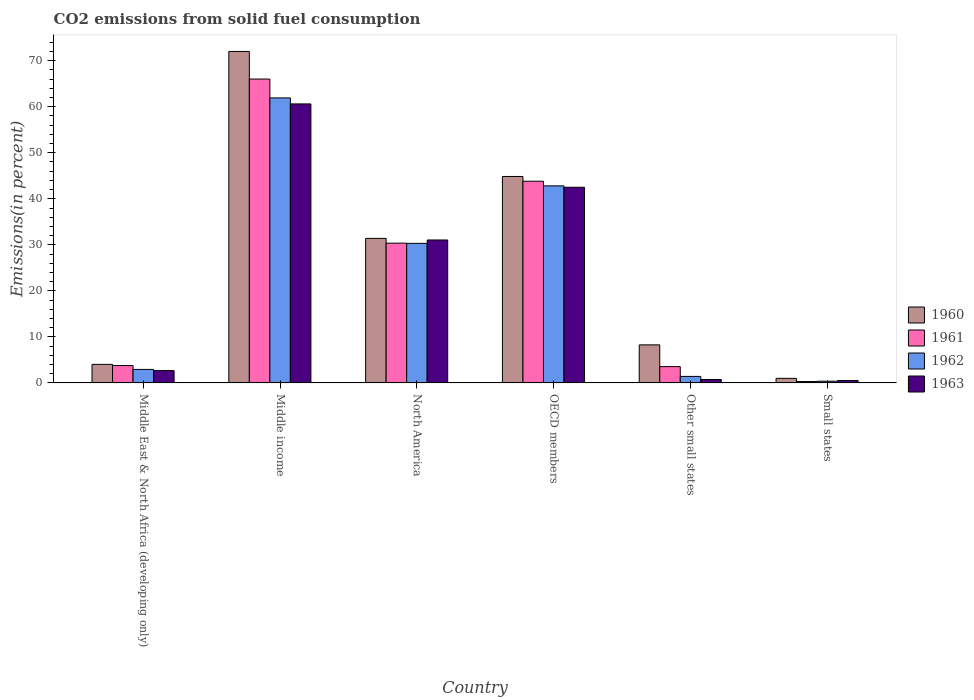How many different coloured bars are there?
Your answer should be very brief. 4. How many groups of bars are there?
Provide a short and direct response. 6. Are the number of bars per tick equal to the number of legend labels?
Give a very brief answer. Yes. What is the label of the 5th group of bars from the left?
Ensure brevity in your answer.  Other small states. What is the total CO2 emitted in 1963 in OECD members?
Keep it short and to the point. 42.51. Across all countries, what is the maximum total CO2 emitted in 1960?
Keep it short and to the point. 72.02. Across all countries, what is the minimum total CO2 emitted in 1961?
Provide a short and direct response. 0.31. In which country was the total CO2 emitted in 1963 minimum?
Your answer should be very brief. Small states. What is the total total CO2 emitted in 1962 in the graph?
Give a very brief answer. 139.8. What is the difference between the total CO2 emitted in 1961 in Middle income and that in Small states?
Your response must be concise. 65.71. What is the difference between the total CO2 emitted in 1962 in Middle income and the total CO2 emitted in 1960 in Other small states?
Keep it short and to the point. 53.65. What is the average total CO2 emitted in 1962 per country?
Keep it short and to the point. 23.3. What is the difference between the total CO2 emitted of/in 1961 and total CO2 emitted of/in 1962 in Middle East & North Africa (developing only)?
Ensure brevity in your answer.  0.84. What is the ratio of the total CO2 emitted in 1962 in Middle income to that in North America?
Offer a terse response. 2.04. Is the total CO2 emitted in 1961 in North America less than that in Small states?
Give a very brief answer. No. Is the difference between the total CO2 emitted in 1961 in Middle income and Other small states greater than the difference between the total CO2 emitted in 1962 in Middle income and Other small states?
Your answer should be very brief. Yes. What is the difference between the highest and the second highest total CO2 emitted in 1961?
Offer a very short reply. 22.2. What is the difference between the highest and the lowest total CO2 emitted in 1963?
Make the answer very short. 60.09. Is it the case that in every country, the sum of the total CO2 emitted in 1960 and total CO2 emitted in 1961 is greater than the total CO2 emitted in 1963?
Give a very brief answer. Yes. How many bars are there?
Make the answer very short. 24. How many countries are there in the graph?
Make the answer very short. 6. How are the legend labels stacked?
Give a very brief answer. Vertical. What is the title of the graph?
Your answer should be very brief. CO2 emissions from solid fuel consumption. What is the label or title of the Y-axis?
Offer a very short reply. Emissions(in percent). What is the Emissions(in percent) in 1960 in Middle East & North Africa (developing only)?
Your answer should be very brief. 4.03. What is the Emissions(in percent) of 1961 in Middle East & North Africa (developing only)?
Ensure brevity in your answer.  3.78. What is the Emissions(in percent) in 1962 in Middle East & North Africa (developing only)?
Your response must be concise. 2.94. What is the Emissions(in percent) of 1963 in Middle East & North Africa (developing only)?
Offer a very short reply. 2.68. What is the Emissions(in percent) of 1960 in Middle income?
Keep it short and to the point. 72.02. What is the Emissions(in percent) of 1961 in Middle income?
Your answer should be compact. 66.02. What is the Emissions(in percent) of 1962 in Middle income?
Your answer should be very brief. 61.92. What is the Emissions(in percent) in 1963 in Middle income?
Provide a succinct answer. 60.62. What is the Emissions(in percent) in 1960 in North America?
Your answer should be very brief. 31.4. What is the Emissions(in percent) in 1961 in North America?
Keep it short and to the point. 30.37. What is the Emissions(in percent) in 1962 in North America?
Offer a terse response. 30.32. What is the Emissions(in percent) in 1963 in North America?
Offer a very short reply. 31.06. What is the Emissions(in percent) of 1960 in OECD members?
Your answer should be very brief. 44.86. What is the Emissions(in percent) in 1961 in OECD members?
Provide a short and direct response. 43.82. What is the Emissions(in percent) in 1962 in OECD members?
Your answer should be very brief. 42.82. What is the Emissions(in percent) in 1963 in OECD members?
Your response must be concise. 42.51. What is the Emissions(in percent) of 1960 in Other small states?
Give a very brief answer. 8.27. What is the Emissions(in percent) in 1961 in Other small states?
Your response must be concise. 3.55. What is the Emissions(in percent) of 1962 in Other small states?
Ensure brevity in your answer.  1.42. What is the Emissions(in percent) in 1963 in Other small states?
Your answer should be very brief. 0.75. What is the Emissions(in percent) of 1960 in Small states?
Your response must be concise. 1. What is the Emissions(in percent) of 1961 in Small states?
Make the answer very short. 0.31. What is the Emissions(in percent) of 1962 in Small states?
Give a very brief answer. 0.38. What is the Emissions(in percent) of 1963 in Small states?
Your response must be concise. 0.53. Across all countries, what is the maximum Emissions(in percent) in 1960?
Give a very brief answer. 72.02. Across all countries, what is the maximum Emissions(in percent) in 1961?
Offer a very short reply. 66.02. Across all countries, what is the maximum Emissions(in percent) of 1962?
Offer a terse response. 61.92. Across all countries, what is the maximum Emissions(in percent) of 1963?
Make the answer very short. 60.62. Across all countries, what is the minimum Emissions(in percent) in 1960?
Offer a very short reply. 1. Across all countries, what is the minimum Emissions(in percent) of 1961?
Offer a terse response. 0.31. Across all countries, what is the minimum Emissions(in percent) of 1962?
Give a very brief answer. 0.38. Across all countries, what is the minimum Emissions(in percent) in 1963?
Your answer should be very brief. 0.53. What is the total Emissions(in percent) of 1960 in the graph?
Offer a very short reply. 161.58. What is the total Emissions(in percent) of 1961 in the graph?
Give a very brief answer. 147.84. What is the total Emissions(in percent) of 1962 in the graph?
Your response must be concise. 139.8. What is the total Emissions(in percent) in 1963 in the graph?
Offer a terse response. 138.15. What is the difference between the Emissions(in percent) in 1960 in Middle East & North Africa (developing only) and that in Middle income?
Give a very brief answer. -67.99. What is the difference between the Emissions(in percent) of 1961 in Middle East & North Africa (developing only) and that in Middle income?
Offer a terse response. -62.24. What is the difference between the Emissions(in percent) of 1962 in Middle East & North Africa (developing only) and that in Middle income?
Keep it short and to the point. -58.99. What is the difference between the Emissions(in percent) in 1963 in Middle East & North Africa (developing only) and that in Middle income?
Offer a terse response. -57.94. What is the difference between the Emissions(in percent) in 1960 in Middle East & North Africa (developing only) and that in North America?
Offer a very short reply. -27.37. What is the difference between the Emissions(in percent) in 1961 in Middle East & North Africa (developing only) and that in North America?
Provide a succinct answer. -26.59. What is the difference between the Emissions(in percent) in 1962 in Middle East & North Africa (developing only) and that in North America?
Keep it short and to the point. -27.38. What is the difference between the Emissions(in percent) in 1963 in Middle East & North Africa (developing only) and that in North America?
Ensure brevity in your answer.  -28.38. What is the difference between the Emissions(in percent) of 1960 in Middle East & North Africa (developing only) and that in OECD members?
Provide a succinct answer. -40.82. What is the difference between the Emissions(in percent) of 1961 in Middle East & North Africa (developing only) and that in OECD members?
Offer a terse response. -40.05. What is the difference between the Emissions(in percent) in 1962 in Middle East & North Africa (developing only) and that in OECD members?
Offer a very short reply. -39.88. What is the difference between the Emissions(in percent) in 1963 in Middle East & North Africa (developing only) and that in OECD members?
Your response must be concise. -39.83. What is the difference between the Emissions(in percent) in 1960 in Middle East & North Africa (developing only) and that in Other small states?
Offer a terse response. -4.24. What is the difference between the Emissions(in percent) in 1961 in Middle East & North Africa (developing only) and that in Other small states?
Keep it short and to the point. 0.23. What is the difference between the Emissions(in percent) in 1962 in Middle East & North Africa (developing only) and that in Other small states?
Give a very brief answer. 1.52. What is the difference between the Emissions(in percent) of 1963 in Middle East & North Africa (developing only) and that in Other small states?
Offer a terse response. 1.93. What is the difference between the Emissions(in percent) of 1960 in Middle East & North Africa (developing only) and that in Small states?
Provide a succinct answer. 3.03. What is the difference between the Emissions(in percent) of 1961 in Middle East & North Africa (developing only) and that in Small states?
Offer a terse response. 3.47. What is the difference between the Emissions(in percent) of 1962 in Middle East & North Africa (developing only) and that in Small states?
Ensure brevity in your answer.  2.56. What is the difference between the Emissions(in percent) of 1963 in Middle East & North Africa (developing only) and that in Small states?
Offer a very short reply. 2.15. What is the difference between the Emissions(in percent) of 1960 in Middle income and that in North America?
Offer a terse response. 40.61. What is the difference between the Emissions(in percent) in 1961 in Middle income and that in North America?
Provide a short and direct response. 35.65. What is the difference between the Emissions(in percent) of 1962 in Middle income and that in North America?
Give a very brief answer. 31.6. What is the difference between the Emissions(in percent) in 1963 in Middle income and that in North America?
Offer a very short reply. 29.56. What is the difference between the Emissions(in percent) of 1960 in Middle income and that in OECD members?
Offer a terse response. 27.16. What is the difference between the Emissions(in percent) of 1961 in Middle income and that in OECD members?
Your response must be concise. 22.2. What is the difference between the Emissions(in percent) of 1962 in Middle income and that in OECD members?
Provide a succinct answer. 19.11. What is the difference between the Emissions(in percent) of 1963 in Middle income and that in OECD members?
Offer a terse response. 18.11. What is the difference between the Emissions(in percent) of 1960 in Middle income and that in Other small states?
Provide a short and direct response. 63.75. What is the difference between the Emissions(in percent) in 1961 in Middle income and that in Other small states?
Offer a terse response. 62.47. What is the difference between the Emissions(in percent) of 1962 in Middle income and that in Other small states?
Make the answer very short. 60.51. What is the difference between the Emissions(in percent) in 1963 in Middle income and that in Other small states?
Offer a very short reply. 59.87. What is the difference between the Emissions(in percent) in 1960 in Middle income and that in Small states?
Offer a terse response. 71.02. What is the difference between the Emissions(in percent) of 1961 in Middle income and that in Small states?
Provide a short and direct response. 65.71. What is the difference between the Emissions(in percent) in 1962 in Middle income and that in Small states?
Provide a short and direct response. 61.55. What is the difference between the Emissions(in percent) in 1963 in Middle income and that in Small states?
Provide a succinct answer. 60.09. What is the difference between the Emissions(in percent) of 1960 in North America and that in OECD members?
Give a very brief answer. -13.45. What is the difference between the Emissions(in percent) in 1961 in North America and that in OECD members?
Ensure brevity in your answer.  -13.45. What is the difference between the Emissions(in percent) of 1962 in North America and that in OECD members?
Give a very brief answer. -12.49. What is the difference between the Emissions(in percent) of 1963 in North America and that in OECD members?
Your answer should be compact. -11.45. What is the difference between the Emissions(in percent) of 1960 in North America and that in Other small states?
Offer a terse response. 23.13. What is the difference between the Emissions(in percent) of 1961 in North America and that in Other small states?
Provide a succinct answer. 26.82. What is the difference between the Emissions(in percent) of 1962 in North America and that in Other small states?
Keep it short and to the point. 28.9. What is the difference between the Emissions(in percent) in 1963 in North America and that in Other small states?
Keep it short and to the point. 30.31. What is the difference between the Emissions(in percent) of 1960 in North America and that in Small states?
Your answer should be very brief. 30.4. What is the difference between the Emissions(in percent) of 1961 in North America and that in Small states?
Your answer should be compact. 30.06. What is the difference between the Emissions(in percent) in 1962 in North America and that in Small states?
Make the answer very short. 29.95. What is the difference between the Emissions(in percent) of 1963 in North America and that in Small states?
Your answer should be very brief. 30.53. What is the difference between the Emissions(in percent) in 1960 in OECD members and that in Other small states?
Offer a terse response. 36.58. What is the difference between the Emissions(in percent) of 1961 in OECD members and that in Other small states?
Offer a very short reply. 40.28. What is the difference between the Emissions(in percent) of 1962 in OECD members and that in Other small states?
Provide a succinct answer. 41.4. What is the difference between the Emissions(in percent) in 1963 in OECD members and that in Other small states?
Your answer should be compact. 41.77. What is the difference between the Emissions(in percent) of 1960 in OECD members and that in Small states?
Keep it short and to the point. 43.86. What is the difference between the Emissions(in percent) in 1961 in OECD members and that in Small states?
Your response must be concise. 43.52. What is the difference between the Emissions(in percent) of 1962 in OECD members and that in Small states?
Provide a short and direct response. 42.44. What is the difference between the Emissions(in percent) in 1963 in OECD members and that in Small states?
Offer a very short reply. 41.98. What is the difference between the Emissions(in percent) in 1960 in Other small states and that in Small states?
Your response must be concise. 7.27. What is the difference between the Emissions(in percent) of 1961 in Other small states and that in Small states?
Offer a terse response. 3.24. What is the difference between the Emissions(in percent) in 1962 in Other small states and that in Small states?
Make the answer very short. 1.04. What is the difference between the Emissions(in percent) of 1963 in Other small states and that in Small states?
Provide a succinct answer. 0.21. What is the difference between the Emissions(in percent) in 1960 in Middle East & North Africa (developing only) and the Emissions(in percent) in 1961 in Middle income?
Offer a terse response. -61.99. What is the difference between the Emissions(in percent) in 1960 in Middle East & North Africa (developing only) and the Emissions(in percent) in 1962 in Middle income?
Provide a succinct answer. -57.89. What is the difference between the Emissions(in percent) in 1960 in Middle East & North Africa (developing only) and the Emissions(in percent) in 1963 in Middle income?
Your answer should be very brief. -56.59. What is the difference between the Emissions(in percent) of 1961 in Middle East & North Africa (developing only) and the Emissions(in percent) of 1962 in Middle income?
Your answer should be compact. -58.15. What is the difference between the Emissions(in percent) in 1961 in Middle East & North Africa (developing only) and the Emissions(in percent) in 1963 in Middle income?
Offer a terse response. -56.84. What is the difference between the Emissions(in percent) in 1962 in Middle East & North Africa (developing only) and the Emissions(in percent) in 1963 in Middle income?
Give a very brief answer. -57.68. What is the difference between the Emissions(in percent) in 1960 in Middle East & North Africa (developing only) and the Emissions(in percent) in 1961 in North America?
Provide a short and direct response. -26.34. What is the difference between the Emissions(in percent) of 1960 in Middle East & North Africa (developing only) and the Emissions(in percent) of 1962 in North America?
Keep it short and to the point. -26.29. What is the difference between the Emissions(in percent) in 1960 in Middle East & North Africa (developing only) and the Emissions(in percent) in 1963 in North America?
Give a very brief answer. -27.03. What is the difference between the Emissions(in percent) in 1961 in Middle East & North Africa (developing only) and the Emissions(in percent) in 1962 in North America?
Provide a succinct answer. -26.55. What is the difference between the Emissions(in percent) in 1961 in Middle East & North Africa (developing only) and the Emissions(in percent) in 1963 in North America?
Make the answer very short. -27.28. What is the difference between the Emissions(in percent) of 1962 in Middle East & North Africa (developing only) and the Emissions(in percent) of 1963 in North America?
Provide a succinct answer. -28.12. What is the difference between the Emissions(in percent) in 1960 in Middle East & North Africa (developing only) and the Emissions(in percent) in 1961 in OECD members?
Ensure brevity in your answer.  -39.79. What is the difference between the Emissions(in percent) of 1960 in Middle East & North Africa (developing only) and the Emissions(in percent) of 1962 in OECD members?
Your answer should be compact. -38.79. What is the difference between the Emissions(in percent) in 1960 in Middle East & North Africa (developing only) and the Emissions(in percent) in 1963 in OECD members?
Offer a terse response. -38.48. What is the difference between the Emissions(in percent) of 1961 in Middle East & North Africa (developing only) and the Emissions(in percent) of 1962 in OECD members?
Your answer should be very brief. -39.04. What is the difference between the Emissions(in percent) of 1961 in Middle East & North Africa (developing only) and the Emissions(in percent) of 1963 in OECD members?
Keep it short and to the point. -38.74. What is the difference between the Emissions(in percent) in 1962 in Middle East & North Africa (developing only) and the Emissions(in percent) in 1963 in OECD members?
Provide a succinct answer. -39.57. What is the difference between the Emissions(in percent) of 1960 in Middle East & North Africa (developing only) and the Emissions(in percent) of 1961 in Other small states?
Keep it short and to the point. 0.48. What is the difference between the Emissions(in percent) of 1960 in Middle East & North Africa (developing only) and the Emissions(in percent) of 1962 in Other small states?
Give a very brief answer. 2.61. What is the difference between the Emissions(in percent) of 1960 in Middle East & North Africa (developing only) and the Emissions(in percent) of 1963 in Other small states?
Make the answer very short. 3.28. What is the difference between the Emissions(in percent) of 1961 in Middle East & North Africa (developing only) and the Emissions(in percent) of 1962 in Other small states?
Keep it short and to the point. 2.36. What is the difference between the Emissions(in percent) in 1961 in Middle East & North Africa (developing only) and the Emissions(in percent) in 1963 in Other small states?
Make the answer very short. 3.03. What is the difference between the Emissions(in percent) of 1962 in Middle East & North Africa (developing only) and the Emissions(in percent) of 1963 in Other small states?
Your answer should be compact. 2.19. What is the difference between the Emissions(in percent) of 1960 in Middle East & North Africa (developing only) and the Emissions(in percent) of 1961 in Small states?
Give a very brief answer. 3.72. What is the difference between the Emissions(in percent) of 1960 in Middle East & North Africa (developing only) and the Emissions(in percent) of 1962 in Small states?
Offer a very short reply. 3.65. What is the difference between the Emissions(in percent) of 1960 in Middle East & North Africa (developing only) and the Emissions(in percent) of 1963 in Small states?
Offer a very short reply. 3.5. What is the difference between the Emissions(in percent) in 1961 in Middle East & North Africa (developing only) and the Emissions(in percent) in 1962 in Small states?
Your answer should be very brief. 3.4. What is the difference between the Emissions(in percent) in 1961 in Middle East & North Africa (developing only) and the Emissions(in percent) in 1963 in Small states?
Your response must be concise. 3.24. What is the difference between the Emissions(in percent) of 1962 in Middle East & North Africa (developing only) and the Emissions(in percent) of 1963 in Small states?
Provide a succinct answer. 2.4. What is the difference between the Emissions(in percent) in 1960 in Middle income and the Emissions(in percent) in 1961 in North America?
Offer a terse response. 41.65. What is the difference between the Emissions(in percent) of 1960 in Middle income and the Emissions(in percent) of 1962 in North America?
Keep it short and to the point. 41.7. What is the difference between the Emissions(in percent) in 1960 in Middle income and the Emissions(in percent) in 1963 in North America?
Offer a terse response. 40.96. What is the difference between the Emissions(in percent) of 1961 in Middle income and the Emissions(in percent) of 1962 in North America?
Your answer should be compact. 35.7. What is the difference between the Emissions(in percent) in 1961 in Middle income and the Emissions(in percent) in 1963 in North America?
Your answer should be very brief. 34.96. What is the difference between the Emissions(in percent) in 1962 in Middle income and the Emissions(in percent) in 1963 in North America?
Your response must be concise. 30.86. What is the difference between the Emissions(in percent) of 1960 in Middle income and the Emissions(in percent) of 1961 in OECD members?
Offer a terse response. 28.2. What is the difference between the Emissions(in percent) in 1960 in Middle income and the Emissions(in percent) in 1962 in OECD members?
Offer a very short reply. 29.2. What is the difference between the Emissions(in percent) in 1960 in Middle income and the Emissions(in percent) in 1963 in OECD members?
Offer a very short reply. 29.51. What is the difference between the Emissions(in percent) in 1961 in Middle income and the Emissions(in percent) in 1962 in OECD members?
Ensure brevity in your answer.  23.2. What is the difference between the Emissions(in percent) in 1961 in Middle income and the Emissions(in percent) in 1963 in OECD members?
Offer a very short reply. 23.51. What is the difference between the Emissions(in percent) in 1962 in Middle income and the Emissions(in percent) in 1963 in OECD members?
Provide a succinct answer. 19.41. What is the difference between the Emissions(in percent) in 1960 in Middle income and the Emissions(in percent) in 1961 in Other small states?
Your answer should be very brief. 68.47. What is the difference between the Emissions(in percent) in 1960 in Middle income and the Emissions(in percent) in 1962 in Other small states?
Your answer should be compact. 70.6. What is the difference between the Emissions(in percent) of 1960 in Middle income and the Emissions(in percent) of 1963 in Other small states?
Ensure brevity in your answer.  71.27. What is the difference between the Emissions(in percent) in 1961 in Middle income and the Emissions(in percent) in 1962 in Other small states?
Your answer should be very brief. 64.6. What is the difference between the Emissions(in percent) of 1961 in Middle income and the Emissions(in percent) of 1963 in Other small states?
Your answer should be very brief. 65.27. What is the difference between the Emissions(in percent) in 1962 in Middle income and the Emissions(in percent) in 1963 in Other small states?
Your answer should be compact. 61.18. What is the difference between the Emissions(in percent) of 1960 in Middle income and the Emissions(in percent) of 1961 in Small states?
Provide a short and direct response. 71.71. What is the difference between the Emissions(in percent) in 1960 in Middle income and the Emissions(in percent) in 1962 in Small states?
Keep it short and to the point. 71.64. What is the difference between the Emissions(in percent) of 1960 in Middle income and the Emissions(in percent) of 1963 in Small states?
Provide a short and direct response. 71.48. What is the difference between the Emissions(in percent) in 1961 in Middle income and the Emissions(in percent) in 1962 in Small states?
Give a very brief answer. 65.64. What is the difference between the Emissions(in percent) in 1961 in Middle income and the Emissions(in percent) in 1963 in Small states?
Provide a short and direct response. 65.48. What is the difference between the Emissions(in percent) in 1962 in Middle income and the Emissions(in percent) in 1963 in Small states?
Offer a very short reply. 61.39. What is the difference between the Emissions(in percent) of 1960 in North America and the Emissions(in percent) of 1961 in OECD members?
Keep it short and to the point. -12.42. What is the difference between the Emissions(in percent) of 1960 in North America and the Emissions(in percent) of 1962 in OECD members?
Ensure brevity in your answer.  -11.41. What is the difference between the Emissions(in percent) of 1960 in North America and the Emissions(in percent) of 1963 in OECD members?
Provide a succinct answer. -11.11. What is the difference between the Emissions(in percent) of 1961 in North America and the Emissions(in percent) of 1962 in OECD members?
Make the answer very short. -12.45. What is the difference between the Emissions(in percent) of 1961 in North America and the Emissions(in percent) of 1963 in OECD members?
Keep it short and to the point. -12.14. What is the difference between the Emissions(in percent) in 1962 in North America and the Emissions(in percent) in 1963 in OECD members?
Your answer should be very brief. -12.19. What is the difference between the Emissions(in percent) in 1960 in North America and the Emissions(in percent) in 1961 in Other small states?
Provide a short and direct response. 27.86. What is the difference between the Emissions(in percent) in 1960 in North America and the Emissions(in percent) in 1962 in Other small states?
Offer a very short reply. 29.98. What is the difference between the Emissions(in percent) in 1960 in North America and the Emissions(in percent) in 1963 in Other small states?
Provide a short and direct response. 30.66. What is the difference between the Emissions(in percent) in 1961 in North America and the Emissions(in percent) in 1962 in Other small states?
Your answer should be very brief. 28.95. What is the difference between the Emissions(in percent) of 1961 in North America and the Emissions(in percent) of 1963 in Other small states?
Provide a short and direct response. 29.62. What is the difference between the Emissions(in percent) of 1962 in North America and the Emissions(in percent) of 1963 in Other small states?
Make the answer very short. 29.58. What is the difference between the Emissions(in percent) of 1960 in North America and the Emissions(in percent) of 1961 in Small states?
Your answer should be compact. 31.1. What is the difference between the Emissions(in percent) of 1960 in North America and the Emissions(in percent) of 1962 in Small states?
Provide a short and direct response. 31.03. What is the difference between the Emissions(in percent) in 1960 in North America and the Emissions(in percent) in 1963 in Small states?
Give a very brief answer. 30.87. What is the difference between the Emissions(in percent) of 1961 in North America and the Emissions(in percent) of 1962 in Small states?
Offer a very short reply. 29.99. What is the difference between the Emissions(in percent) in 1961 in North America and the Emissions(in percent) in 1963 in Small states?
Make the answer very short. 29.84. What is the difference between the Emissions(in percent) in 1962 in North America and the Emissions(in percent) in 1963 in Small states?
Make the answer very short. 29.79. What is the difference between the Emissions(in percent) of 1960 in OECD members and the Emissions(in percent) of 1961 in Other small states?
Provide a succinct answer. 41.31. What is the difference between the Emissions(in percent) in 1960 in OECD members and the Emissions(in percent) in 1962 in Other small states?
Offer a very short reply. 43.44. What is the difference between the Emissions(in percent) in 1960 in OECD members and the Emissions(in percent) in 1963 in Other small states?
Offer a very short reply. 44.11. What is the difference between the Emissions(in percent) of 1961 in OECD members and the Emissions(in percent) of 1962 in Other small states?
Offer a terse response. 42.4. What is the difference between the Emissions(in percent) in 1961 in OECD members and the Emissions(in percent) in 1963 in Other small states?
Make the answer very short. 43.08. What is the difference between the Emissions(in percent) in 1962 in OECD members and the Emissions(in percent) in 1963 in Other small states?
Give a very brief answer. 42.07. What is the difference between the Emissions(in percent) of 1960 in OECD members and the Emissions(in percent) of 1961 in Small states?
Offer a terse response. 44.55. What is the difference between the Emissions(in percent) of 1960 in OECD members and the Emissions(in percent) of 1962 in Small states?
Your response must be concise. 44.48. What is the difference between the Emissions(in percent) of 1960 in OECD members and the Emissions(in percent) of 1963 in Small states?
Your answer should be very brief. 44.32. What is the difference between the Emissions(in percent) in 1961 in OECD members and the Emissions(in percent) in 1962 in Small states?
Keep it short and to the point. 43.45. What is the difference between the Emissions(in percent) of 1961 in OECD members and the Emissions(in percent) of 1963 in Small states?
Make the answer very short. 43.29. What is the difference between the Emissions(in percent) of 1962 in OECD members and the Emissions(in percent) of 1963 in Small states?
Make the answer very short. 42.28. What is the difference between the Emissions(in percent) in 1960 in Other small states and the Emissions(in percent) in 1961 in Small states?
Offer a terse response. 7.96. What is the difference between the Emissions(in percent) of 1960 in Other small states and the Emissions(in percent) of 1962 in Small states?
Provide a short and direct response. 7.89. What is the difference between the Emissions(in percent) in 1960 in Other small states and the Emissions(in percent) in 1963 in Small states?
Your answer should be compact. 7.74. What is the difference between the Emissions(in percent) in 1961 in Other small states and the Emissions(in percent) in 1962 in Small states?
Provide a short and direct response. 3.17. What is the difference between the Emissions(in percent) of 1961 in Other small states and the Emissions(in percent) of 1963 in Small states?
Provide a succinct answer. 3.01. What is the difference between the Emissions(in percent) in 1962 in Other small states and the Emissions(in percent) in 1963 in Small states?
Offer a very short reply. 0.88. What is the average Emissions(in percent) of 1960 per country?
Your answer should be compact. 26.93. What is the average Emissions(in percent) in 1961 per country?
Your answer should be very brief. 24.64. What is the average Emissions(in percent) of 1962 per country?
Give a very brief answer. 23.3. What is the average Emissions(in percent) of 1963 per country?
Keep it short and to the point. 23.03. What is the difference between the Emissions(in percent) in 1960 and Emissions(in percent) in 1961 in Middle East & North Africa (developing only)?
Keep it short and to the point. 0.25. What is the difference between the Emissions(in percent) in 1960 and Emissions(in percent) in 1962 in Middle East & North Africa (developing only)?
Your response must be concise. 1.09. What is the difference between the Emissions(in percent) of 1960 and Emissions(in percent) of 1963 in Middle East & North Africa (developing only)?
Ensure brevity in your answer.  1.35. What is the difference between the Emissions(in percent) in 1961 and Emissions(in percent) in 1962 in Middle East & North Africa (developing only)?
Offer a very short reply. 0.84. What is the difference between the Emissions(in percent) of 1961 and Emissions(in percent) of 1963 in Middle East & North Africa (developing only)?
Your answer should be compact. 1.1. What is the difference between the Emissions(in percent) of 1962 and Emissions(in percent) of 1963 in Middle East & North Africa (developing only)?
Give a very brief answer. 0.26. What is the difference between the Emissions(in percent) in 1960 and Emissions(in percent) in 1961 in Middle income?
Offer a very short reply. 6. What is the difference between the Emissions(in percent) of 1960 and Emissions(in percent) of 1962 in Middle income?
Give a very brief answer. 10.09. What is the difference between the Emissions(in percent) of 1960 and Emissions(in percent) of 1963 in Middle income?
Offer a terse response. 11.4. What is the difference between the Emissions(in percent) of 1961 and Emissions(in percent) of 1962 in Middle income?
Give a very brief answer. 4.09. What is the difference between the Emissions(in percent) in 1961 and Emissions(in percent) in 1963 in Middle income?
Your answer should be very brief. 5.4. What is the difference between the Emissions(in percent) in 1962 and Emissions(in percent) in 1963 in Middle income?
Your response must be concise. 1.31. What is the difference between the Emissions(in percent) in 1960 and Emissions(in percent) in 1961 in North America?
Provide a succinct answer. 1.03. What is the difference between the Emissions(in percent) in 1960 and Emissions(in percent) in 1962 in North America?
Your answer should be compact. 1.08. What is the difference between the Emissions(in percent) in 1960 and Emissions(in percent) in 1963 in North America?
Give a very brief answer. 0.34. What is the difference between the Emissions(in percent) of 1961 and Emissions(in percent) of 1962 in North America?
Provide a succinct answer. 0.05. What is the difference between the Emissions(in percent) in 1961 and Emissions(in percent) in 1963 in North America?
Make the answer very short. -0.69. What is the difference between the Emissions(in percent) of 1962 and Emissions(in percent) of 1963 in North America?
Your answer should be very brief. -0.74. What is the difference between the Emissions(in percent) of 1960 and Emissions(in percent) of 1961 in OECD members?
Keep it short and to the point. 1.03. What is the difference between the Emissions(in percent) in 1960 and Emissions(in percent) in 1962 in OECD members?
Give a very brief answer. 2.04. What is the difference between the Emissions(in percent) in 1960 and Emissions(in percent) in 1963 in OECD members?
Offer a terse response. 2.34. What is the difference between the Emissions(in percent) in 1961 and Emissions(in percent) in 1963 in OECD members?
Your response must be concise. 1.31. What is the difference between the Emissions(in percent) of 1962 and Emissions(in percent) of 1963 in OECD members?
Offer a very short reply. 0.3. What is the difference between the Emissions(in percent) in 1960 and Emissions(in percent) in 1961 in Other small states?
Ensure brevity in your answer.  4.72. What is the difference between the Emissions(in percent) of 1960 and Emissions(in percent) of 1962 in Other small states?
Offer a very short reply. 6.85. What is the difference between the Emissions(in percent) in 1960 and Emissions(in percent) in 1963 in Other small states?
Your answer should be very brief. 7.52. What is the difference between the Emissions(in percent) in 1961 and Emissions(in percent) in 1962 in Other small states?
Your answer should be very brief. 2.13. What is the difference between the Emissions(in percent) in 1961 and Emissions(in percent) in 1963 in Other small states?
Offer a very short reply. 2.8. What is the difference between the Emissions(in percent) of 1962 and Emissions(in percent) of 1963 in Other small states?
Your answer should be very brief. 0.67. What is the difference between the Emissions(in percent) in 1960 and Emissions(in percent) in 1961 in Small states?
Give a very brief answer. 0.69. What is the difference between the Emissions(in percent) of 1960 and Emissions(in percent) of 1962 in Small states?
Provide a short and direct response. 0.62. What is the difference between the Emissions(in percent) in 1960 and Emissions(in percent) in 1963 in Small states?
Your response must be concise. 0.46. What is the difference between the Emissions(in percent) in 1961 and Emissions(in percent) in 1962 in Small states?
Keep it short and to the point. -0.07. What is the difference between the Emissions(in percent) of 1961 and Emissions(in percent) of 1963 in Small states?
Your response must be concise. -0.23. What is the difference between the Emissions(in percent) of 1962 and Emissions(in percent) of 1963 in Small states?
Your answer should be very brief. -0.16. What is the ratio of the Emissions(in percent) of 1960 in Middle East & North Africa (developing only) to that in Middle income?
Offer a very short reply. 0.06. What is the ratio of the Emissions(in percent) in 1961 in Middle East & North Africa (developing only) to that in Middle income?
Provide a succinct answer. 0.06. What is the ratio of the Emissions(in percent) of 1962 in Middle East & North Africa (developing only) to that in Middle income?
Provide a short and direct response. 0.05. What is the ratio of the Emissions(in percent) in 1963 in Middle East & North Africa (developing only) to that in Middle income?
Offer a very short reply. 0.04. What is the ratio of the Emissions(in percent) in 1960 in Middle East & North Africa (developing only) to that in North America?
Ensure brevity in your answer.  0.13. What is the ratio of the Emissions(in percent) of 1961 in Middle East & North Africa (developing only) to that in North America?
Your answer should be compact. 0.12. What is the ratio of the Emissions(in percent) of 1962 in Middle East & North Africa (developing only) to that in North America?
Make the answer very short. 0.1. What is the ratio of the Emissions(in percent) of 1963 in Middle East & North Africa (developing only) to that in North America?
Ensure brevity in your answer.  0.09. What is the ratio of the Emissions(in percent) in 1960 in Middle East & North Africa (developing only) to that in OECD members?
Keep it short and to the point. 0.09. What is the ratio of the Emissions(in percent) of 1961 in Middle East & North Africa (developing only) to that in OECD members?
Ensure brevity in your answer.  0.09. What is the ratio of the Emissions(in percent) of 1962 in Middle East & North Africa (developing only) to that in OECD members?
Keep it short and to the point. 0.07. What is the ratio of the Emissions(in percent) in 1963 in Middle East & North Africa (developing only) to that in OECD members?
Make the answer very short. 0.06. What is the ratio of the Emissions(in percent) of 1960 in Middle East & North Africa (developing only) to that in Other small states?
Provide a succinct answer. 0.49. What is the ratio of the Emissions(in percent) in 1961 in Middle East & North Africa (developing only) to that in Other small states?
Provide a short and direct response. 1.06. What is the ratio of the Emissions(in percent) of 1962 in Middle East & North Africa (developing only) to that in Other small states?
Provide a succinct answer. 2.07. What is the ratio of the Emissions(in percent) of 1963 in Middle East & North Africa (developing only) to that in Other small states?
Offer a terse response. 3.59. What is the ratio of the Emissions(in percent) in 1960 in Middle East & North Africa (developing only) to that in Small states?
Your response must be concise. 4.04. What is the ratio of the Emissions(in percent) of 1961 in Middle East & North Africa (developing only) to that in Small states?
Your response must be concise. 12.35. What is the ratio of the Emissions(in percent) of 1962 in Middle East & North Africa (developing only) to that in Small states?
Make the answer very short. 7.81. What is the ratio of the Emissions(in percent) of 1963 in Middle East & North Africa (developing only) to that in Small states?
Ensure brevity in your answer.  5.02. What is the ratio of the Emissions(in percent) of 1960 in Middle income to that in North America?
Offer a terse response. 2.29. What is the ratio of the Emissions(in percent) in 1961 in Middle income to that in North America?
Keep it short and to the point. 2.17. What is the ratio of the Emissions(in percent) of 1962 in Middle income to that in North America?
Your answer should be compact. 2.04. What is the ratio of the Emissions(in percent) of 1963 in Middle income to that in North America?
Your answer should be very brief. 1.95. What is the ratio of the Emissions(in percent) in 1960 in Middle income to that in OECD members?
Give a very brief answer. 1.61. What is the ratio of the Emissions(in percent) of 1961 in Middle income to that in OECD members?
Give a very brief answer. 1.51. What is the ratio of the Emissions(in percent) in 1962 in Middle income to that in OECD members?
Provide a succinct answer. 1.45. What is the ratio of the Emissions(in percent) in 1963 in Middle income to that in OECD members?
Your answer should be very brief. 1.43. What is the ratio of the Emissions(in percent) of 1960 in Middle income to that in Other small states?
Provide a short and direct response. 8.71. What is the ratio of the Emissions(in percent) of 1961 in Middle income to that in Other small states?
Provide a short and direct response. 18.62. What is the ratio of the Emissions(in percent) in 1962 in Middle income to that in Other small states?
Keep it short and to the point. 43.66. What is the ratio of the Emissions(in percent) in 1963 in Middle income to that in Other small states?
Make the answer very short. 81.23. What is the ratio of the Emissions(in percent) in 1960 in Middle income to that in Small states?
Your answer should be very brief. 72.14. What is the ratio of the Emissions(in percent) of 1961 in Middle income to that in Small states?
Your answer should be very brief. 215.88. What is the ratio of the Emissions(in percent) of 1962 in Middle income to that in Small states?
Your response must be concise. 164.53. What is the ratio of the Emissions(in percent) of 1963 in Middle income to that in Small states?
Offer a very short reply. 113.6. What is the ratio of the Emissions(in percent) in 1960 in North America to that in OECD members?
Your answer should be compact. 0.7. What is the ratio of the Emissions(in percent) in 1961 in North America to that in OECD members?
Your answer should be compact. 0.69. What is the ratio of the Emissions(in percent) in 1962 in North America to that in OECD members?
Give a very brief answer. 0.71. What is the ratio of the Emissions(in percent) in 1963 in North America to that in OECD members?
Your answer should be compact. 0.73. What is the ratio of the Emissions(in percent) in 1960 in North America to that in Other small states?
Offer a terse response. 3.8. What is the ratio of the Emissions(in percent) of 1961 in North America to that in Other small states?
Offer a terse response. 8.56. What is the ratio of the Emissions(in percent) in 1962 in North America to that in Other small states?
Keep it short and to the point. 21.38. What is the ratio of the Emissions(in percent) of 1963 in North America to that in Other small states?
Keep it short and to the point. 41.62. What is the ratio of the Emissions(in percent) in 1960 in North America to that in Small states?
Your answer should be very brief. 31.46. What is the ratio of the Emissions(in percent) in 1961 in North America to that in Small states?
Your answer should be compact. 99.31. What is the ratio of the Emissions(in percent) of 1962 in North America to that in Small states?
Provide a short and direct response. 80.56. What is the ratio of the Emissions(in percent) of 1963 in North America to that in Small states?
Your response must be concise. 58.21. What is the ratio of the Emissions(in percent) in 1960 in OECD members to that in Other small states?
Your response must be concise. 5.42. What is the ratio of the Emissions(in percent) of 1961 in OECD members to that in Other small states?
Ensure brevity in your answer.  12.36. What is the ratio of the Emissions(in percent) of 1962 in OECD members to that in Other small states?
Ensure brevity in your answer.  30.19. What is the ratio of the Emissions(in percent) in 1963 in OECD members to that in Other small states?
Your response must be concise. 56.97. What is the ratio of the Emissions(in percent) in 1960 in OECD members to that in Small states?
Make the answer very short. 44.93. What is the ratio of the Emissions(in percent) in 1961 in OECD members to that in Small states?
Make the answer very short. 143.3. What is the ratio of the Emissions(in percent) in 1962 in OECD members to that in Small states?
Your answer should be compact. 113.76. What is the ratio of the Emissions(in percent) of 1963 in OECD members to that in Small states?
Ensure brevity in your answer.  79.67. What is the ratio of the Emissions(in percent) of 1960 in Other small states to that in Small states?
Make the answer very short. 8.28. What is the ratio of the Emissions(in percent) of 1961 in Other small states to that in Small states?
Keep it short and to the point. 11.6. What is the ratio of the Emissions(in percent) of 1962 in Other small states to that in Small states?
Your answer should be compact. 3.77. What is the ratio of the Emissions(in percent) in 1963 in Other small states to that in Small states?
Offer a very short reply. 1.4. What is the difference between the highest and the second highest Emissions(in percent) of 1960?
Your response must be concise. 27.16. What is the difference between the highest and the second highest Emissions(in percent) in 1961?
Provide a short and direct response. 22.2. What is the difference between the highest and the second highest Emissions(in percent) of 1962?
Offer a very short reply. 19.11. What is the difference between the highest and the second highest Emissions(in percent) of 1963?
Make the answer very short. 18.11. What is the difference between the highest and the lowest Emissions(in percent) of 1960?
Offer a terse response. 71.02. What is the difference between the highest and the lowest Emissions(in percent) in 1961?
Your answer should be compact. 65.71. What is the difference between the highest and the lowest Emissions(in percent) of 1962?
Keep it short and to the point. 61.55. What is the difference between the highest and the lowest Emissions(in percent) of 1963?
Give a very brief answer. 60.09. 